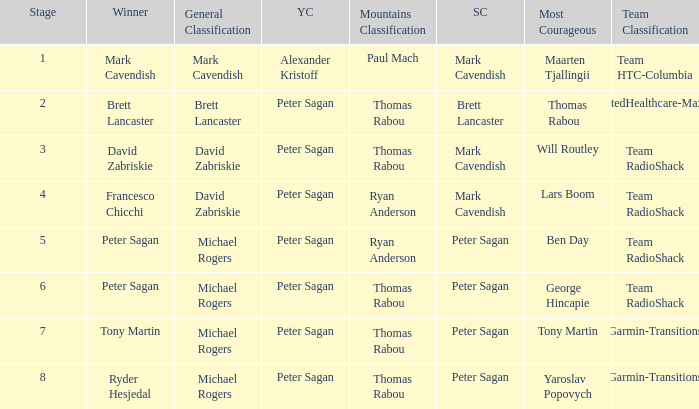When Peter Sagan won the youth classification and Thomas Rabou won the most corageous, who won the sprint classification? Brett Lancaster. 